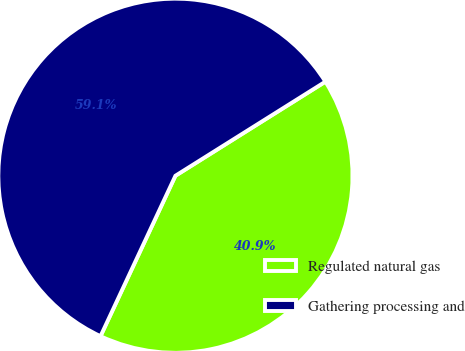Convert chart to OTSL. <chart><loc_0><loc_0><loc_500><loc_500><pie_chart><fcel>Regulated natural gas<fcel>Gathering processing and<nl><fcel>40.87%<fcel>59.13%<nl></chart> 